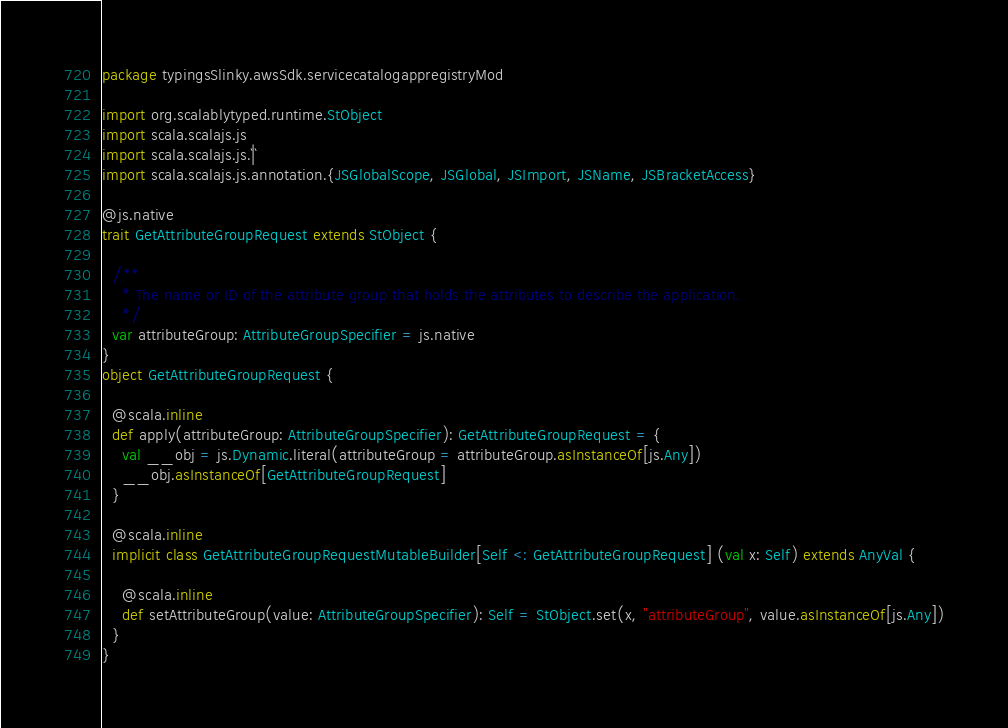<code> <loc_0><loc_0><loc_500><loc_500><_Scala_>package typingsSlinky.awsSdk.servicecatalogappregistryMod

import org.scalablytyped.runtime.StObject
import scala.scalajs.js
import scala.scalajs.js.`|`
import scala.scalajs.js.annotation.{JSGlobalScope, JSGlobal, JSImport, JSName, JSBracketAccess}

@js.native
trait GetAttributeGroupRequest extends StObject {
  
  /**
    * The name or ID of the attribute group that holds the attributes to describe the application.
    */
  var attributeGroup: AttributeGroupSpecifier = js.native
}
object GetAttributeGroupRequest {
  
  @scala.inline
  def apply(attributeGroup: AttributeGroupSpecifier): GetAttributeGroupRequest = {
    val __obj = js.Dynamic.literal(attributeGroup = attributeGroup.asInstanceOf[js.Any])
    __obj.asInstanceOf[GetAttributeGroupRequest]
  }
  
  @scala.inline
  implicit class GetAttributeGroupRequestMutableBuilder[Self <: GetAttributeGroupRequest] (val x: Self) extends AnyVal {
    
    @scala.inline
    def setAttributeGroup(value: AttributeGroupSpecifier): Self = StObject.set(x, "attributeGroup", value.asInstanceOf[js.Any])
  }
}
</code> 